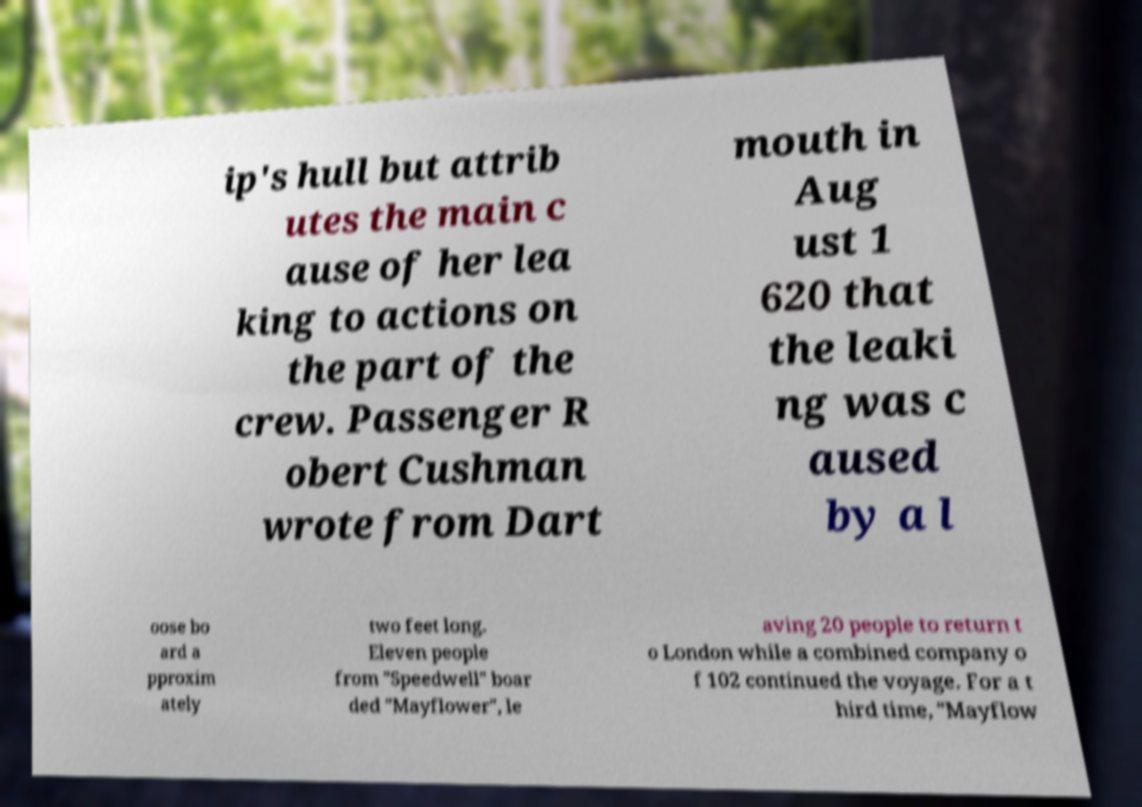Could you extract and type out the text from this image? ip's hull but attrib utes the main c ause of her lea king to actions on the part of the crew. Passenger R obert Cushman wrote from Dart mouth in Aug ust 1 620 that the leaki ng was c aused by a l oose bo ard a pproxim ately two feet long. Eleven people from "Speedwell" boar ded "Mayflower", le aving 20 people to return t o London while a combined company o f 102 continued the voyage. For a t hird time, "Mayflow 